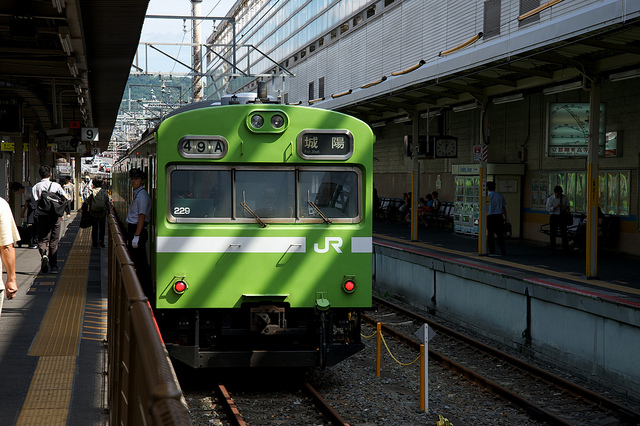Identify the text displayed in this image. JR 49A 229 9 